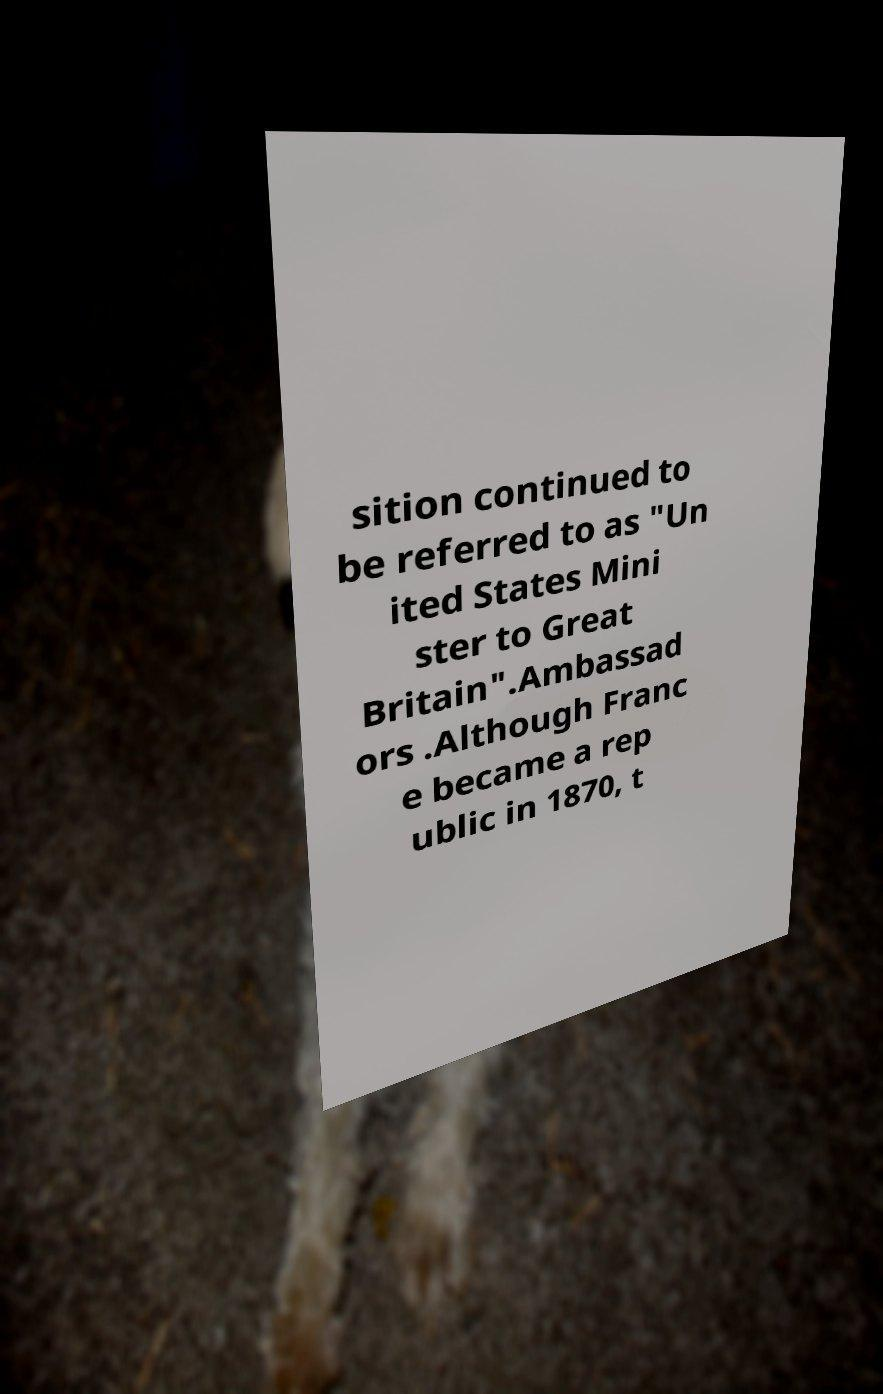Can you accurately transcribe the text from the provided image for me? sition continued to be referred to as "Un ited States Mini ster to Great Britain".Ambassad ors .Although Franc e became a rep ublic in 1870, t 